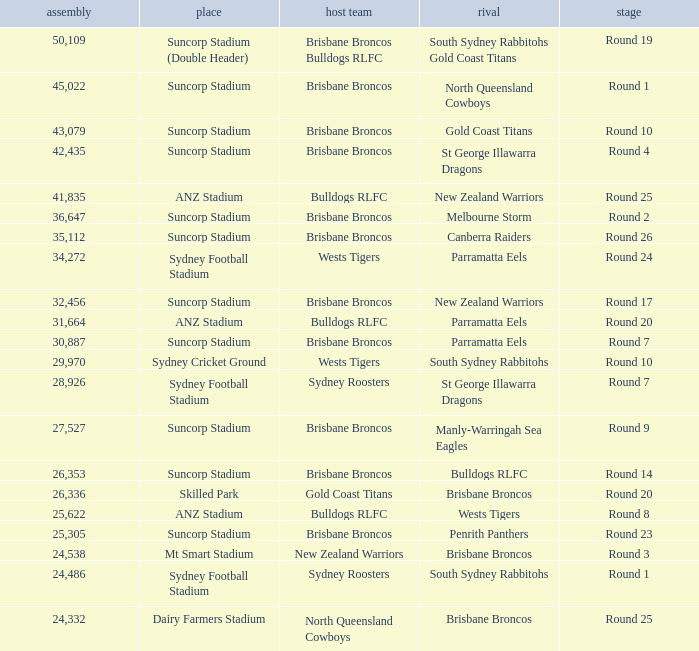What was the attendance at Round 9? 1.0. 